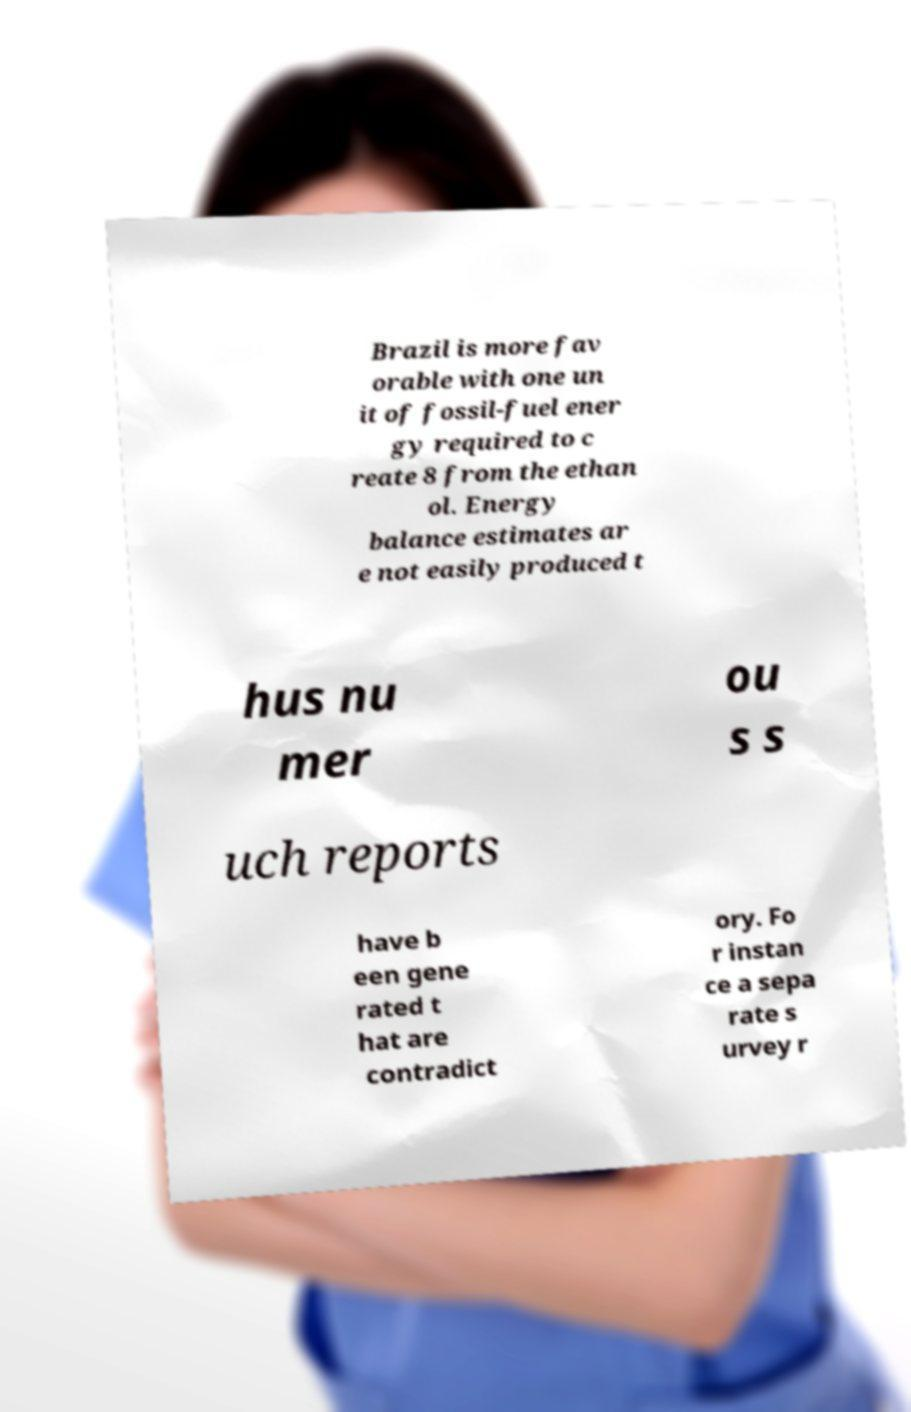What messages or text are displayed in this image? I need them in a readable, typed format. Brazil is more fav orable with one un it of fossil-fuel ener gy required to c reate 8 from the ethan ol. Energy balance estimates ar e not easily produced t hus nu mer ou s s uch reports have b een gene rated t hat are contradict ory. Fo r instan ce a sepa rate s urvey r 